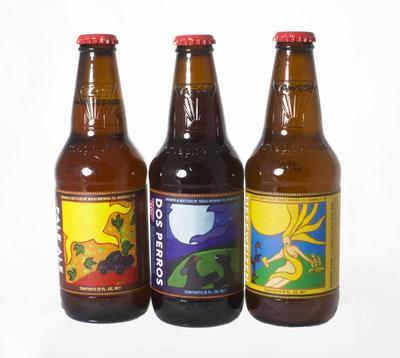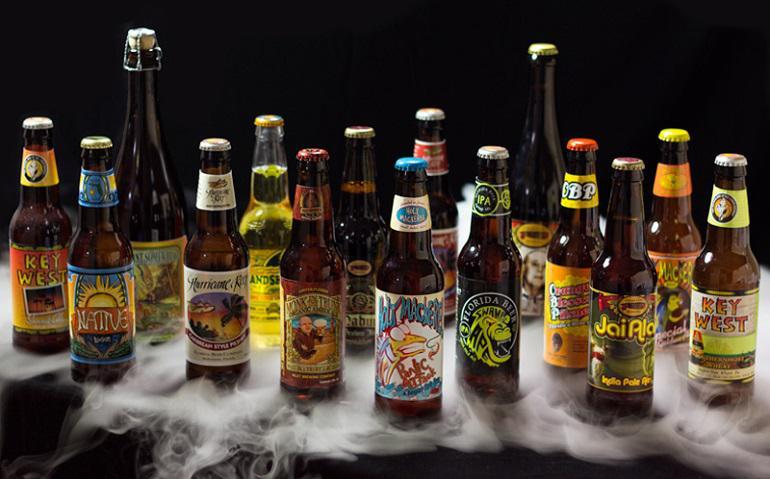The first image is the image on the left, the second image is the image on the right. Examine the images to the left and right. Is the description "In at least one image there are four rows of beer." accurate? Answer yes or no. No. The first image is the image on the left, the second image is the image on the right. For the images displayed, is the sentence "The left image contains at least three times as many bottles as the right image, and the bottles in the right image are displayed on a visible flat surface." factually correct? Answer yes or no. No. 